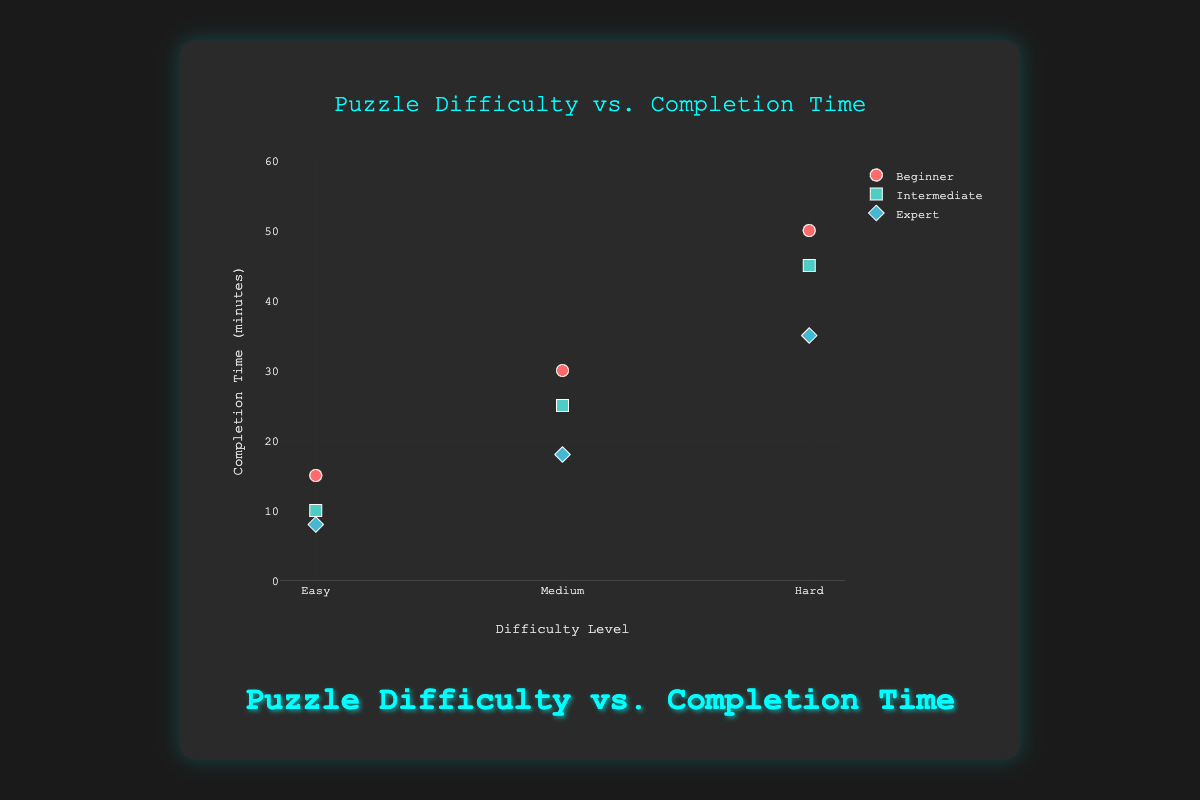How many experience levels are represented in the plot? There are three distinct experience levels represented in the plot, each with different colors and markers: Beginner, Intermediate, and Expert.
Answer: 3 What are the coordinates of the expert player's completion time for the medium difficulty level? The expert player's completion time for the medium difficulty level is located at the "Medium" category on the x-axis and 18 minutes on the y-axis.
Answer: (Medium, 18) Which experience level shows the most significant reduction in completion time as the difficulty level increases from Easy to Hard? To determine this, compare the completion times across difficulty levels for each experience level. The reduction for Beginners is from 15 to 50 minutes, for Intermediates from 10 to 45 minutes, and for Experts from 8 to 35 minutes. The reduction for Beginners is substantial, but it appears that the Intermediate level shows the most consistent reduction trend across all levels.
Answer: Intermediate What is the average completion time for Expert players across all difficulty levels? To find the average, sum the completion times for Expert players for each difficulty level: 8 (Easy) + 18 (Medium) + 35 (Hard) = 61 minutes. Then divide by the number of difficulty levels, which is 3. The average is 61 / 3.
Answer: ~20.3 minutes How does the completion time for Intermediate players on Easy puzzles compare to that of Expert players on Medium puzzles? The completion time for Intermediate players on Easy puzzles is 10 minutes, while the completion time for Expert players on Medium puzzles is 18 minutes. Intermediate players have a shorter completion time on Easy puzzles compared to Expert players on Medium puzzles by 8 minutes.
Answer: 10 vs. 18, Intermediate is faster by 8 minutes Which player experience level has the highest completion time for the Hard difficulty level, and what is that time? To determine this, compare the completion times for Hard difficulty by each experience level. Beginner players have a completion time of 50 minutes, which is higher than Intermediate (45 minutes) and Expert (35 minutes).
Answer: Beginner, 50 minutes How does the completion time trend for Easy puzzles differ between the player experience levels? For Easy puzzles, the completion times are 15 minutes for Beginners, 10 minutes for Intermediate, and 8 minutes for Expert players. The trend shows decreasing times as player experience level increases.
Answer: Decreases with experience What is the total number of data points represented in the plot? Each experience level has completion times for three difficulty levels, resulting in 3 data points per experience level. With three experience levels, the total number of data points is 3 x 3 = 9.
Answer: 9 